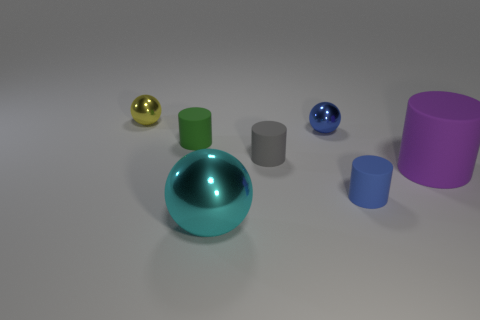Are the objects arranged in a specific pattern? The objects do not appear to follow a formal pattern, however, they are laid out in a manner that provides a balanced visual distribution across the image, with varying heights and colors. 